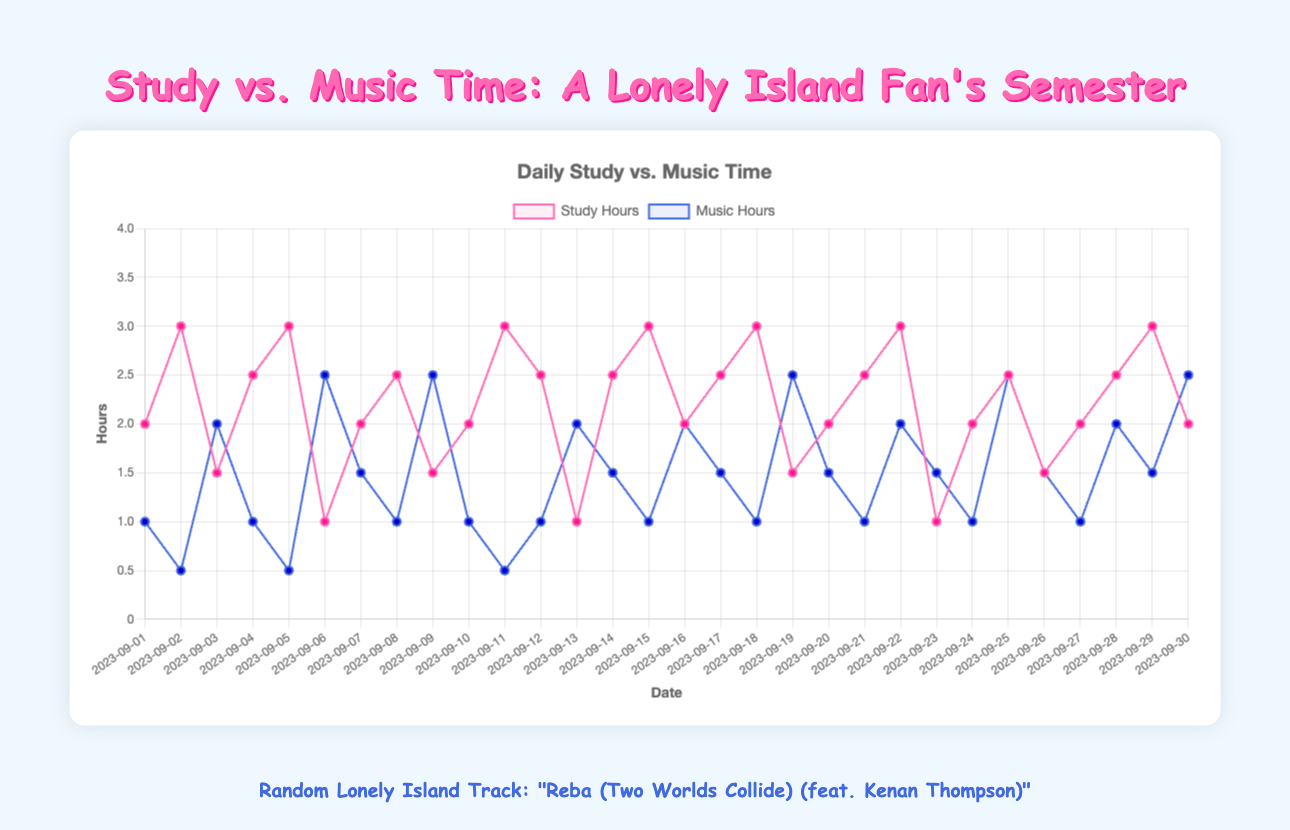What is the total study time for the first five days? Sum the study hours for the first five days: 2 + 3 + 1.5 + 2.5 + 3 = 12 hours
Answer: 12 hours Which day has the highest number of hours spent listening to music? Identify the maximum value in the "music_hours" array and locate the corresponding date: The highest music hours is 2.5 hours on 2023-09-06, 2023-09-09, 2023-09-19, 2023-09-24, and 2023-09-30
Answer: 2023-09-06, 2023-09-09, 2023-09-19, 2023-09-24, and 2023-09-30 On which days is the study time exactly twice the music listening time? Check for days where the value in "study_hours" is double that in "music_hours": 
- 2023-09-01 (2 vs 1)
- 2023-09-04 (2.5 vs 1)
- 2023-09-08 (2.5 vs 1)
- 2023-09-11 (3 vs 0.5)
- 2023-09-21 (2.5 vs 1.5)
Answer: 2023-09-01, 2023-09-04, 2023-09-08, 2023-09-11, 2023-09-21 Compare the average daily study hours with the average daily music listening hours. Which is higher? Calculate both averages: 
- Average study hours = sum(study_hours) / 30 = 62 / 30 ≈ 2.07
- Average music hours = sum(music_hours) / 30 = 43 / 30 ≈ 1.43
2.07 (study hours) is higher than 1.43 (music hours)
Answer: Study hours How many days did the student spend more time listening to music than studying? Identify and count all instances where "music_hours" is greater than "study_hours": 2023-09-03, 2023-09-06, 2023-09-09, 2023-09-13, 2023-09-16, 2023-09-19, 2023-09-24, 2023-09-29, 2023-09-30 = 9 days
Answer: 9 days Is there any day where both study and music hours are equal? Check for any day where the values of "study_hours" and "music_hours" are the same: There are no matching values in the provided datasets
Answer: No What is the difference in study hours between the first and the last day of the month? Subtract the study hours on 2023-09-30 from those on 2023-09-01: 2 (2023-09-01) - 2 (2023-09-30) = 0
Answer: 0 hours Which has more variability over the month: study time or music listening time? Compare the range and standard deviation of both datasets:
- Range of study hours: max(3) - min(1) = 2
- Range of music hours: max(2.5) - min(0.5) = 2
Calculate standard deviations for deeper insight, but the ranges suggest similar variability
Answer: Similar variability (ranges are both 2 hours) 